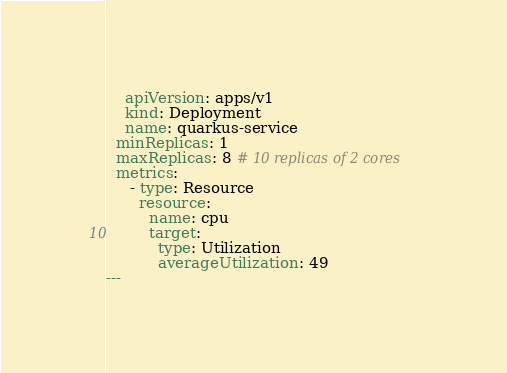<code> <loc_0><loc_0><loc_500><loc_500><_YAML_>    apiVersion: apps/v1
    kind: Deployment
    name: quarkus-service
  minReplicas: 1
  maxReplicas: 8 # 10 replicas of 2 cores
  metrics:
     - type: Resource
       resource:
         name: cpu
         target:
           type: Utilization
           averageUtilization: 49
---
</code> 